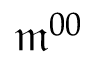<formula> <loc_0><loc_0><loc_500><loc_500>\mathfrak { m } ^ { 0 0 }</formula> 